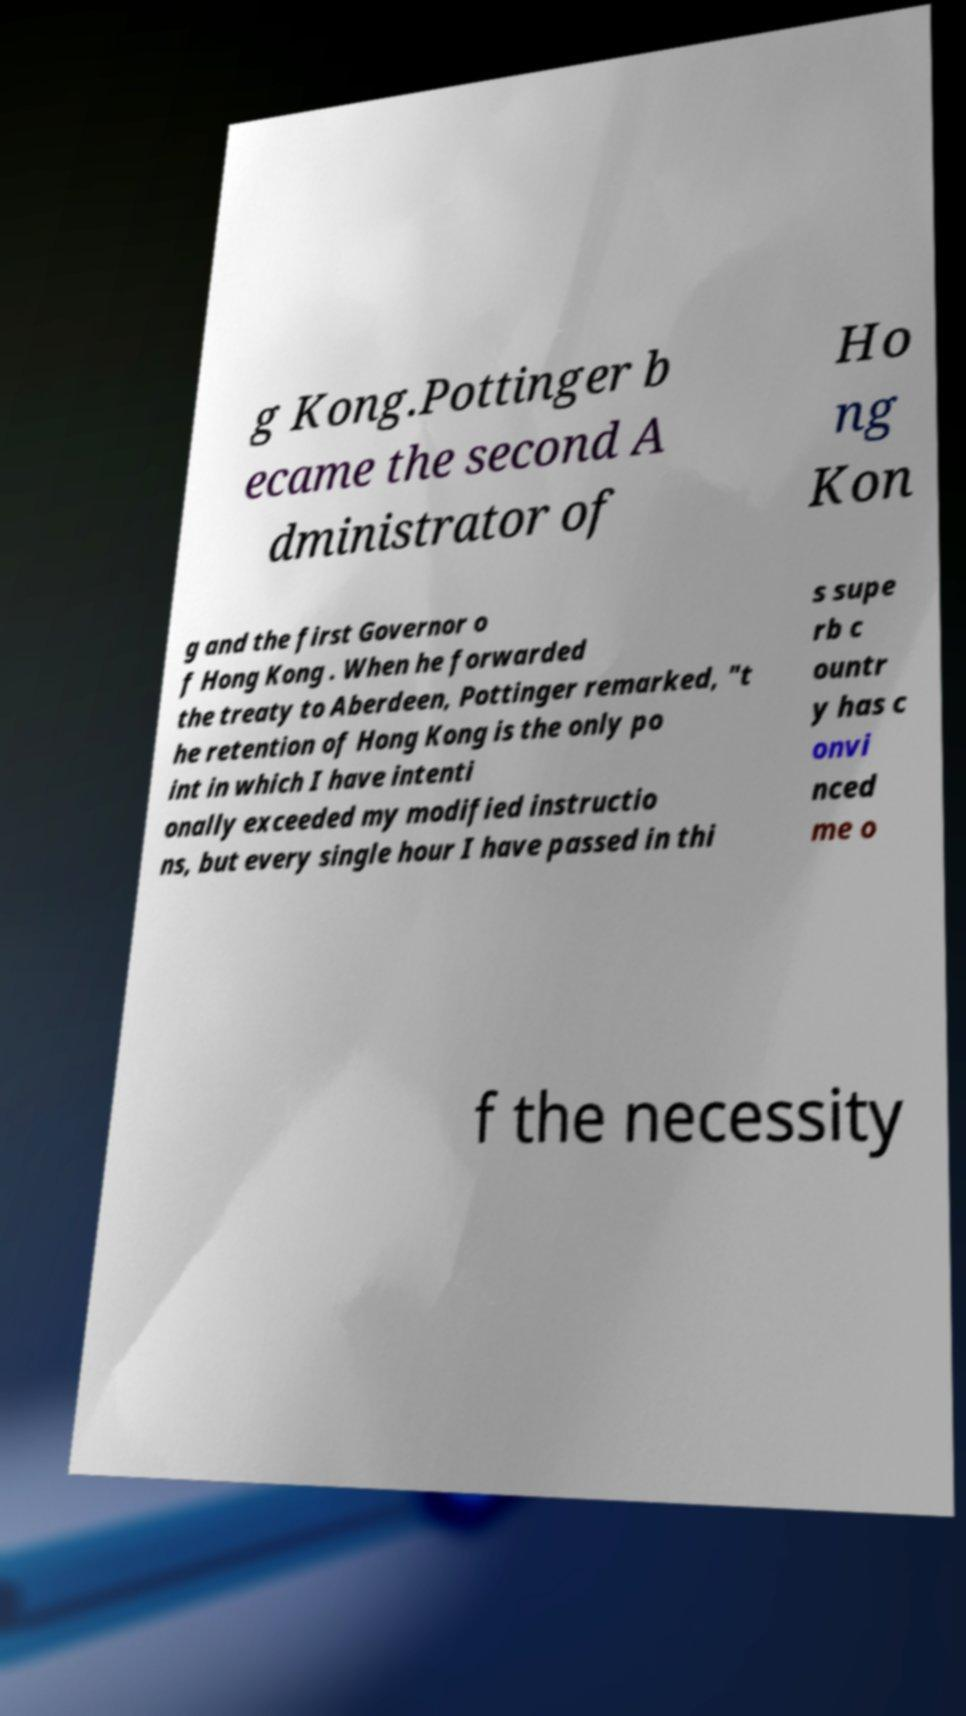Can you accurately transcribe the text from the provided image for me? g Kong.Pottinger b ecame the second A dministrator of Ho ng Kon g and the first Governor o f Hong Kong . When he forwarded the treaty to Aberdeen, Pottinger remarked, "t he retention of Hong Kong is the only po int in which I have intenti onally exceeded my modified instructio ns, but every single hour I have passed in thi s supe rb c ountr y has c onvi nced me o f the necessity 